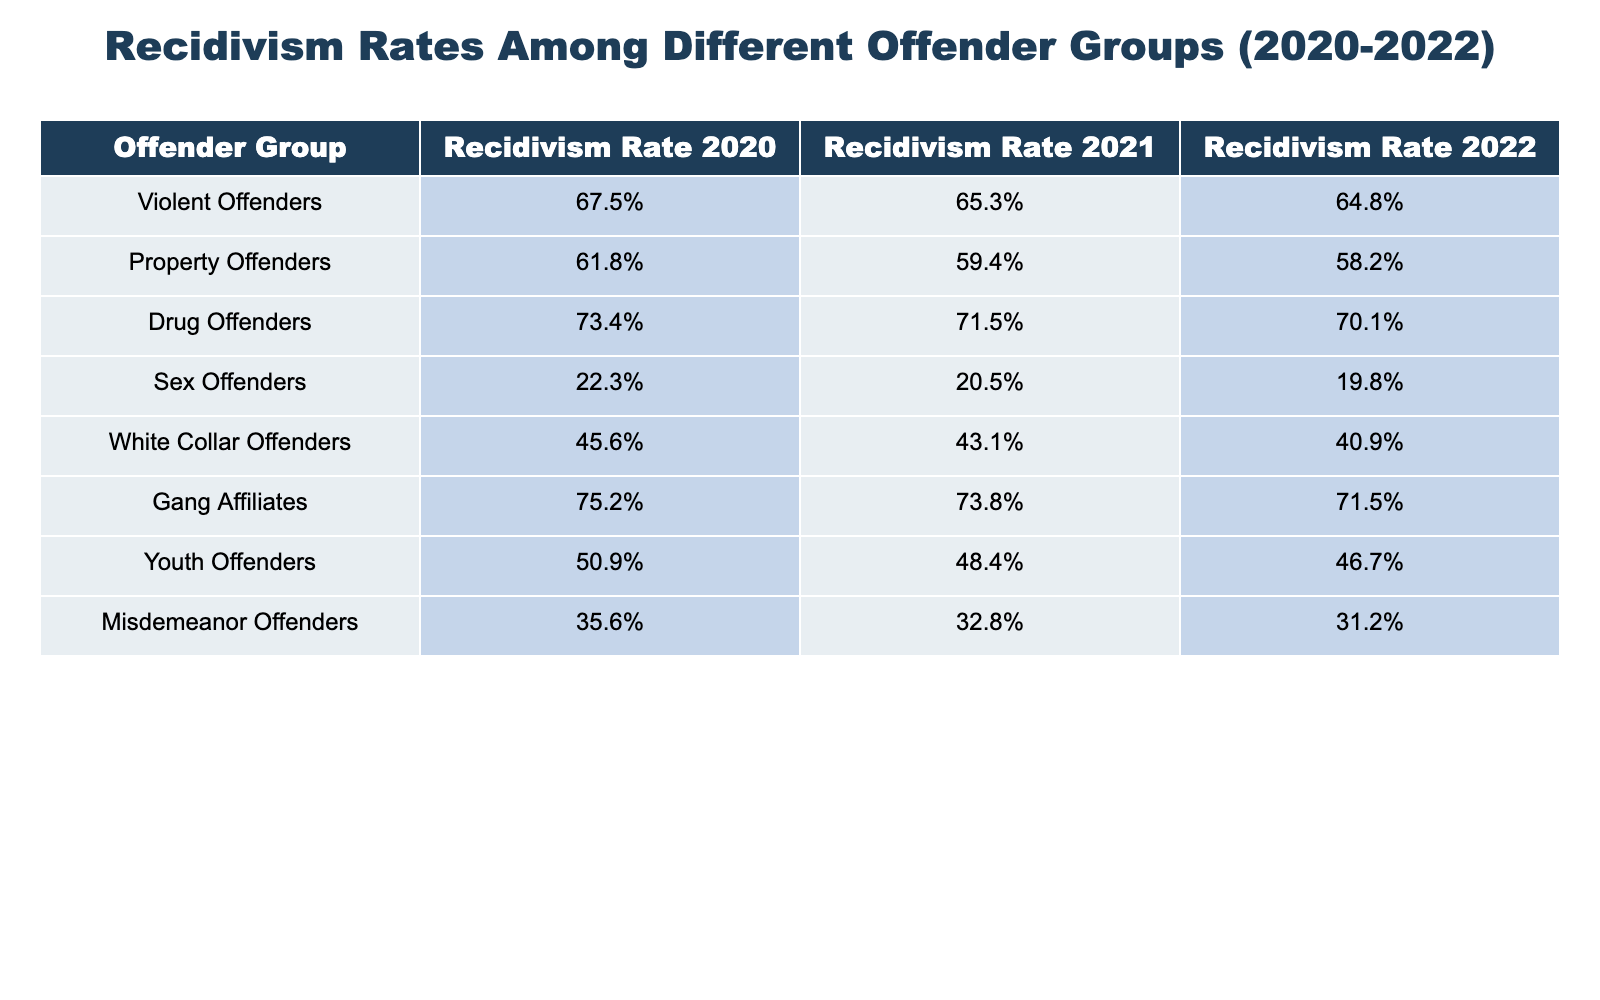What was the recidivism rate for violent offenders in 2020? The table shows that the recidivism rate for violent offenders in 2020 was 67.5%.
Answer: 67.5% Which offender group has the highest recidivism rate in 2022? According to the table, drug offenders have the highest recidivism rate in 2022 at 70.1%.
Answer: Drug offenders What is the difference in recidivism rates for property offenders between 2020 and 2022? The recidivism rate for property offenders in 2020 was 61.8%, and in 2022 it was 58.2%. The difference is 61.8% - 58.2% = 3.6%.
Answer: 3.6% What was the average recidivism rate for the youth offenders from 2020 to 2022? The recidivism rates for youth offenders are 50.9% in 2020, 48.4% in 2021, and 46.7% in 2022. The average is (50.9% + 48.4% + 46.7%)/3 = 48.67%.
Answer: 48.67% Did the recidivism rate for sex offenders decrease every year from 2020 to 2022? The rates are 22.3% in 2020, 20.5% in 2021, and 19.8% in 2022, indicating a decrease each year.
Answer: Yes Is the recidivism rate for gang affiliates higher than that of white-collar offenders in 2021? The recidivism rate for gang affiliates in 2021 is 73.8%, which is higher than that of white-collar offenders at 43.1%.
Answer: Yes What is the change in the recidivism rate for misdemeanor offenders from 2020 to 2022? Misdemeanor offenders had a rate of 35.6% in 2020 and 31.2% in 2022, a change of 35.6% - 31.2% = 4.4%.
Answer: 4.4% What is the recidivism rate for drug offenders in 2021 and how does it compare to that of youth offenders in the same year? Drug offenders had a rate of 71.5% and youth offenders had a rate of 48.4% in 2021. Drug offenders had a significantly higher rate than youth offenders.
Answer: Higher Which offender groups had a recidivism rate below 50% in 2022? The groups with less than 50% recidivism in 2022 are sex offenders (19.8%) and white-collar offenders (40.9%).
Answer: Sex offenders and white-collar offenders What was the overall trend in recidivism rates for property offenders from 2020 to 2022? The rates for property offenders decreased from 61.8% in 2020 to 59.4% in 2021 and to 58.2% in 2022, indicating a clear downward trend.
Answer: Decreasing 